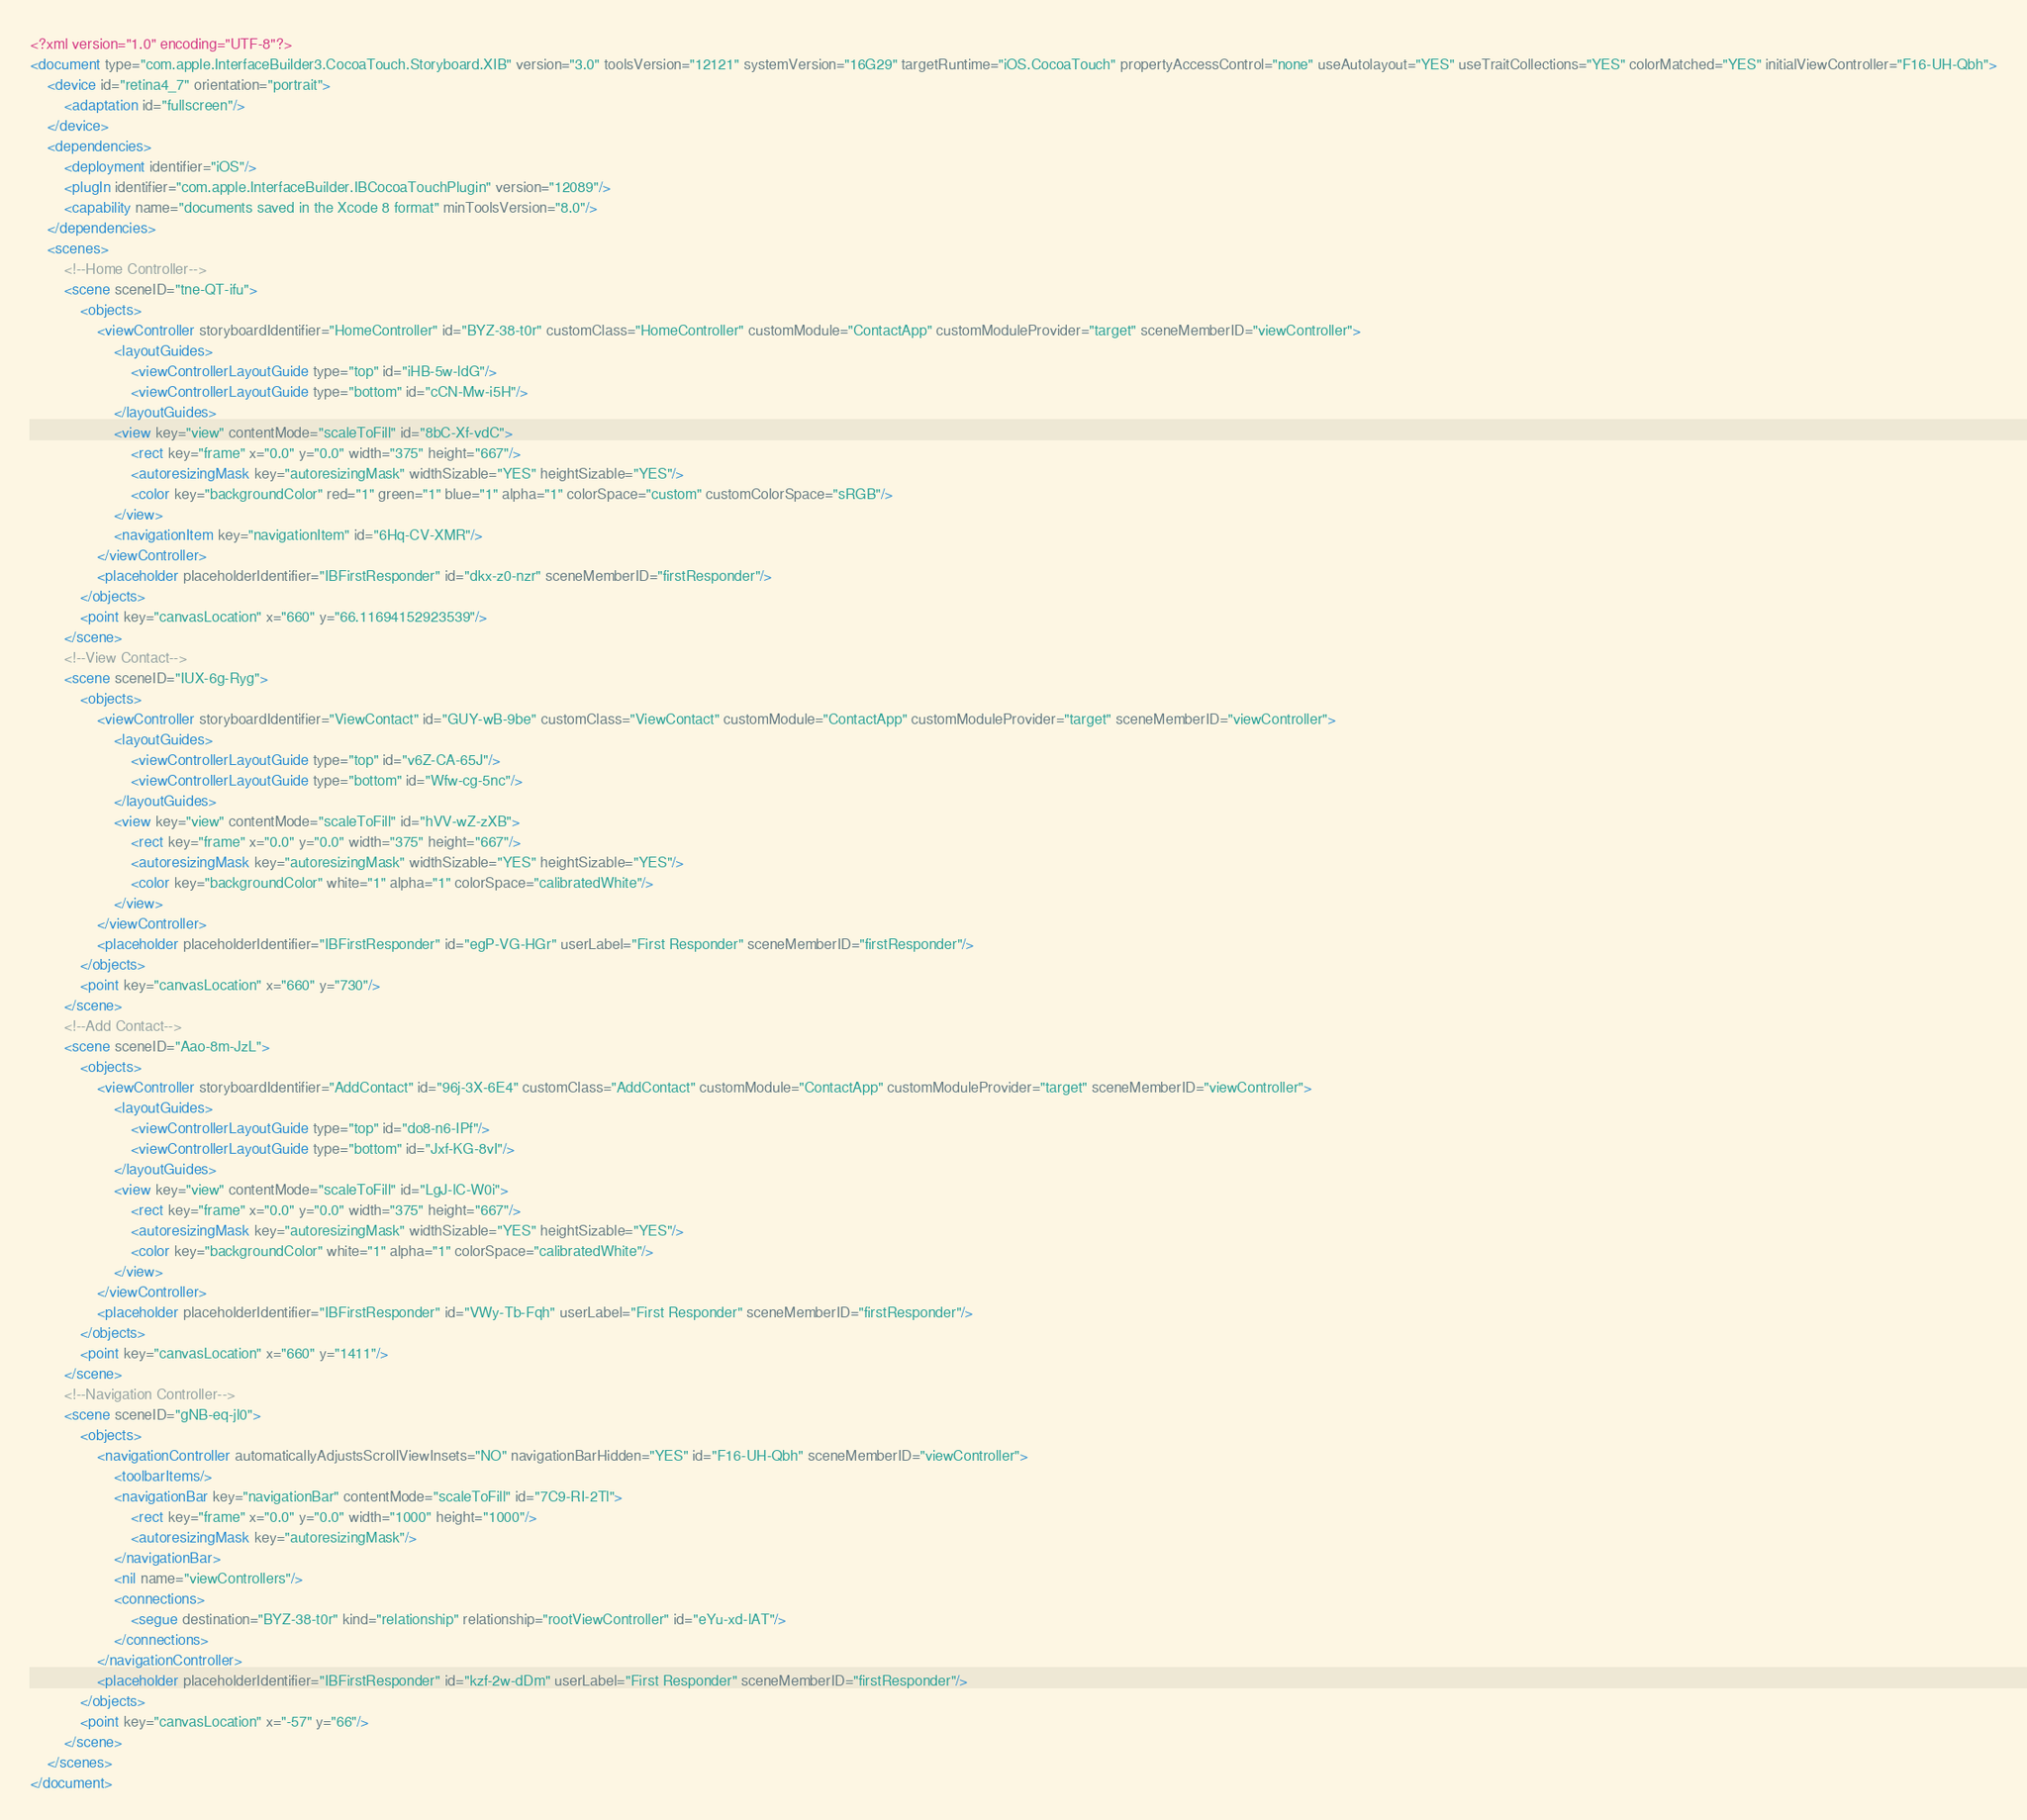<code> <loc_0><loc_0><loc_500><loc_500><_XML_><?xml version="1.0" encoding="UTF-8"?>
<document type="com.apple.InterfaceBuilder3.CocoaTouch.Storyboard.XIB" version="3.0" toolsVersion="12121" systemVersion="16G29" targetRuntime="iOS.CocoaTouch" propertyAccessControl="none" useAutolayout="YES" useTraitCollections="YES" colorMatched="YES" initialViewController="F16-UH-Qbh">
    <device id="retina4_7" orientation="portrait">
        <adaptation id="fullscreen"/>
    </device>
    <dependencies>
        <deployment identifier="iOS"/>
        <plugIn identifier="com.apple.InterfaceBuilder.IBCocoaTouchPlugin" version="12089"/>
        <capability name="documents saved in the Xcode 8 format" minToolsVersion="8.0"/>
    </dependencies>
    <scenes>
        <!--Home Controller-->
        <scene sceneID="tne-QT-ifu">
            <objects>
                <viewController storyboardIdentifier="HomeController" id="BYZ-38-t0r" customClass="HomeController" customModule="ContactApp" customModuleProvider="target" sceneMemberID="viewController">
                    <layoutGuides>
                        <viewControllerLayoutGuide type="top" id="iHB-5w-ldG"/>
                        <viewControllerLayoutGuide type="bottom" id="cCN-Mw-i5H"/>
                    </layoutGuides>
                    <view key="view" contentMode="scaleToFill" id="8bC-Xf-vdC">
                        <rect key="frame" x="0.0" y="0.0" width="375" height="667"/>
                        <autoresizingMask key="autoresizingMask" widthSizable="YES" heightSizable="YES"/>
                        <color key="backgroundColor" red="1" green="1" blue="1" alpha="1" colorSpace="custom" customColorSpace="sRGB"/>
                    </view>
                    <navigationItem key="navigationItem" id="6Hq-CV-XMR"/>
                </viewController>
                <placeholder placeholderIdentifier="IBFirstResponder" id="dkx-z0-nzr" sceneMemberID="firstResponder"/>
            </objects>
            <point key="canvasLocation" x="660" y="66.11694152923539"/>
        </scene>
        <!--View Contact-->
        <scene sceneID="IUX-6g-Ryg">
            <objects>
                <viewController storyboardIdentifier="ViewContact" id="GUY-wB-9be" customClass="ViewContact" customModule="ContactApp" customModuleProvider="target" sceneMemberID="viewController">
                    <layoutGuides>
                        <viewControllerLayoutGuide type="top" id="v6Z-CA-65J"/>
                        <viewControllerLayoutGuide type="bottom" id="Wfw-cg-5nc"/>
                    </layoutGuides>
                    <view key="view" contentMode="scaleToFill" id="hVV-wZ-zXB">
                        <rect key="frame" x="0.0" y="0.0" width="375" height="667"/>
                        <autoresizingMask key="autoresizingMask" widthSizable="YES" heightSizable="YES"/>
                        <color key="backgroundColor" white="1" alpha="1" colorSpace="calibratedWhite"/>
                    </view>
                </viewController>
                <placeholder placeholderIdentifier="IBFirstResponder" id="egP-VG-HGr" userLabel="First Responder" sceneMemberID="firstResponder"/>
            </objects>
            <point key="canvasLocation" x="660" y="730"/>
        </scene>
        <!--Add Contact-->
        <scene sceneID="Aao-8m-JzL">
            <objects>
                <viewController storyboardIdentifier="AddContact" id="96j-3X-6E4" customClass="AddContact" customModule="ContactApp" customModuleProvider="target" sceneMemberID="viewController">
                    <layoutGuides>
                        <viewControllerLayoutGuide type="top" id="do8-n6-IPf"/>
                        <viewControllerLayoutGuide type="bottom" id="Jxf-KG-8vI"/>
                    </layoutGuides>
                    <view key="view" contentMode="scaleToFill" id="LgJ-lC-W0i">
                        <rect key="frame" x="0.0" y="0.0" width="375" height="667"/>
                        <autoresizingMask key="autoresizingMask" widthSizable="YES" heightSizable="YES"/>
                        <color key="backgroundColor" white="1" alpha="1" colorSpace="calibratedWhite"/>
                    </view>
                </viewController>
                <placeholder placeholderIdentifier="IBFirstResponder" id="VWy-Tb-Fqh" userLabel="First Responder" sceneMemberID="firstResponder"/>
            </objects>
            <point key="canvasLocation" x="660" y="1411"/>
        </scene>
        <!--Navigation Controller-->
        <scene sceneID="gNB-eq-jl0">
            <objects>
                <navigationController automaticallyAdjustsScrollViewInsets="NO" navigationBarHidden="YES" id="F16-UH-Qbh" sceneMemberID="viewController">
                    <toolbarItems/>
                    <navigationBar key="navigationBar" contentMode="scaleToFill" id="7C9-RI-2Tl">
                        <rect key="frame" x="0.0" y="0.0" width="1000" height="1000"/>
                        <autoresizingMask key="autoresizingMask"/>
                    </navigationBar>
                    <nil name="viewControllers"/>
                    <connections>
                        <segue destination="BYZ-38-t0r" kind="relationship" relationship="rootViewController" id="eYu-xd-lAT"/>
                    </connections>
                </navigationController>
                <placeholder placeholderIdentifier="IBFirstResponder" id="kzf-2w-dDm" userLabel="First Responder" sceneMemberID="firstResponder"/>
            </objects>
            <point key="canvasLocation" x="-57" y="66"/>
        </scene>
    </scenes>
</document>
</code> 